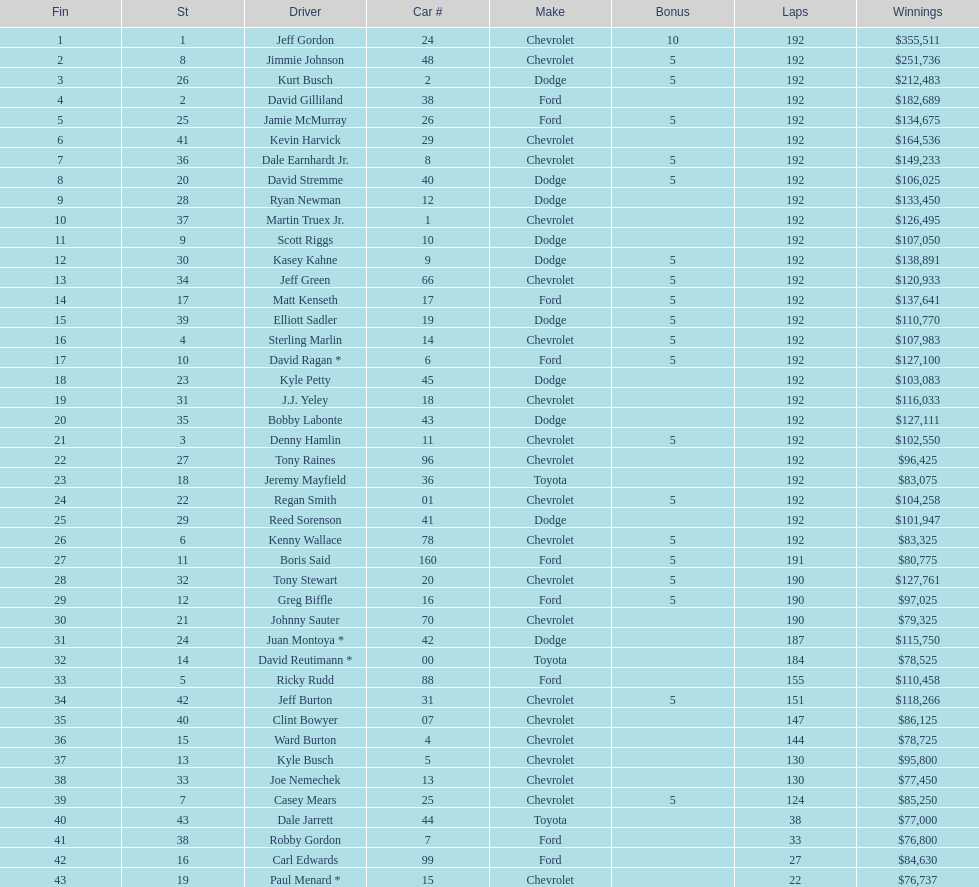What was jimmie johnson's winnings? $251,736. 